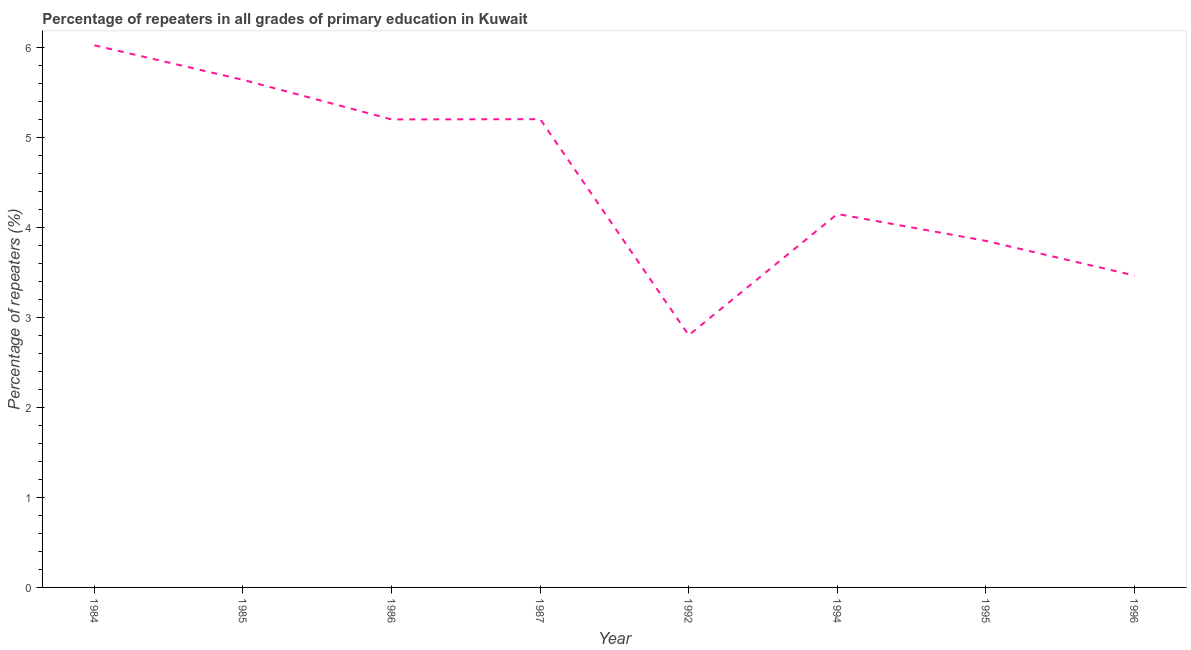What is the percentage of repeaters in primary education in 1994?
Keep it short and to the point. 4.15. Across all years, what is the maximum percentage of repeaters in primary education?
Make the answer very short. 6.03. Across all years, what is the minimum percentage of repeaters in primary education?
Provide a succinct answer. 2.8. What is the sum of the percentage of repeaters in primary education?
Offer a very short reply. 36.35. What is the difference between the percentage of repeaters in primary education in 1985 and 1987?
Ensure brevity in your answer.  0.44. What is the average percentage of repeaters in primary education per year?
Offer a terse response. 4.54. What is the median percentage of repeaters in primary education?
Provide a short and direct response. 4.68. What is the ratio of the percentage of repeaters in primary education in 1986 to that in 1992?
Offer a terse response. 1.86. What is the difference between the highest and the second highest percentage of repeaters in primary education?
Your answer should be compact. 0.38. Is the sum of the percentage of repeaters in primary education in 1987 and 1992 greater than the maximum percentage of repeaters in primary education across all years?
Provide a short and direct response. Yes. What is the difference between the highest and the lowest percentage of repeaters in primary education?
Your answer should be very brief. 3.22. In how many years, is the percentage of repeaters in primary education greater than the average percentage of repeaters in primary education taken over all years?
Keep it short and to the point. 4. Does the percentage of repeaters in primary education monotonically increase over the years?
Give a very brief answer. No. How many lines are there?
Your answer should be very brief. 1. How many years are there in the graph?
Offer a terse response. 8. What is the difference between two consecutive major ticks on the Y-axis?
Make the answer very short. 1. Are the values on the major ticks of Y-axis written in scientific E-notation?
Ensure brevity in your answer.  No. Does the graph contain any zero values?
Ensure brevity in your answer.  No. What is the title of the graph?
Your answer should be very brief. Percentage of repeaters in all grades of primary education in Kuwait. What is the label or title of the Y-axis?
Make the answer very short. Percentage of repeaters (%). What is the Percentage of repeaters (%) in 1984?
Provide a succinct answer. 6.03. What is the Percentage of repeaters (%) in 1985?
Provide a short and direct response. 5.64. What is the Percentage of repeaters (%) of 1986?
Offer a terse response. 5.2. What is the Percentage of repeaters (%) in 1987?
Your answer should be compact. 5.2. What is the Percentage of repeaters (%) of 1992?
Your answer should be compact. 2.8. What is the Percentage of repeaters (%) of 1994?
Your answer should be very brief. 4.15. What is the Percentage of repeaters (%) in 1995?
Your answer should be very brief. 3.85. What is the Percentage of repeaters (%) in 1996?
Provide a short and direct response. 3.47. What is the difference between the Percentage of repeaters (%) in 1984 and 1985?
Offer a very short reply. 0.38. What is the difference between the Percentage of repeaters (%) in 1984 and 1986?
Your response must be concise. 0.82. What is the difference between the Percentage of repeaters (%) in 1984 and 1987?
Make the answer very short. 0.82. What is the difference between the Percentage of repeaters (%) in 1984 and 1992?
Provide a short and direct response. 3.22. What is the difference between the Percentage of repeaters (%) in 1984 and 1994?
Offer a very short reply. 1.87. What is the difference between the Percentage of repeaters (%) in 1984 and 1995?
Ensure brevity in your answer.  2.17. What is the difference between the Percentage of repeaters (%) in 1984 and 1996?
Provide a succinct answer. 2.56. What is the difference between the Percentage of repeaters (%) in 1985 and 1986?
Offer a terse response. 0.44. What is the difference between the Percentage of repeaters (%) in 1985 and 1987?
Your answer should be very brief. 0.44. What is the difference between the Percentage of repeaters (%) in 1985 and 1992?
Keep it short and to the point. 2.84. What is the difference between the Percentage of repeaters (%) in 1985 and 1994?
Your answer should be very brief. 1.49. What is the difference between the Percentage of repeaters (%) in 1985 and 1995?
Offer a very short reply. 1.79. What is the difference between the Percentage of repeaters (%) in 1985 and 1996?
Ensure brevity in your answer.  2.18. What is the difference between the Percentage of repeaters (%) in 1986 and 1987?
Your answer should be compact. -0. What is the difference between the Percentage of repeaters (%) in 1986 and 1992?
Make the answer very short. 2.4. What is the difference between the Percentage of repeaters (%) in 1986 and 1994?
Keep it short and to the point. 1.05. What is the difference between the Percentage of repeaters (%) in 1986 and 1995?
Your answer should be very brief. 1.35. What is the difference between the Percentage of repeaters (%) in 1986 and 1996?
Keep it short and to the point. 1.74. What is the difference between the Percentage of repeaters (%) in 1987 and 1992?
Provide a succinct answer. 2.4. What is the difference between the Percentage of repeaters (%) in 1987 and 1994?
Ensure brevity in your answer.  1.05. What is the difference between the Percentage of repeaters (%) in 1987 and 1995?
Provide a short and direct response. 1.35. What is the difference between the Percentage of repeaters (%) in 1987 and 1996?
Your response must be concise. 1.74. What is the difference between the Percentage of repeaters (%) in 1992 and 1994?
Keep it short and to the point. -1.35. What is the difference between the Percentage of repeaters (%) in 1992 and 1995?
Make the answer very short. -1.05. What is the difference between the Percentage of repeaters (%) in 1992 and 1996?
Keep it short and to the point. -0.66. What is the difference between the Percentage of repeaters (%) in 1994 and 1995?
Make the answer very short. 0.3. What is the difference between the Percentage of repeaters (%) in 1994 and 1996?
Provide a short and direct response. 0.68. What is the difference between the Percentage of repeaters (%) in 1995 and 1996?
Your response must be concise. 0.39. What is the ratio of the Percentage of repeaters (%) in 1984 to that in 1985?
Keep it short and to the point. 1.07. What is the ratio of the Percentage of repeaters (%) in 1984 to that in 1986?
Ensure brevity in your answer.  1.16. What is the ratio of the Percentage of repeaters (%) in 1984 to that in 1987?
Make the answer very short. 1.16. What is the ratio of the Percentage of repeaters (%) in 1984 to that in 1992?
Ensure brevity in your answer.  2.15. What is the ratio of the Percentage of repeaters (%) in 1984 to that in 1994?
Offer a very short reply. 1.45. What is the ratio of the Percentage of repeaters (%) in 1984 to that in 1995?
Ensure brevity in your answer.  1.56. What is the ratio of the Percentage of repeaters (%) in 1984 to that in 1996?
Make the answer very short. 1.74. What is the ratio of the Percentage of repeaters (%) in 1985 to that in 1986?
Ensure brevity in your answer.  1.08. What is the ratio of the Percentage of repeaters (%) in 1985 to that in 1987?
Your answer should be very brief. 1.08. What is the ratio of the Percentage of repeaters (%) in 1985 to that in 1992?
Offer a terse response. 2.01. What is the ratio of the Percentage of repeaters (%) in 1985 to that in 1994?
Ensure brevity in your answer.  1.36. What is the ratio of the Percentage of repeaters (%) in 1985 to that in 1995?
Offer a very short reply. 1.47. What is the ratio of the Percentage of repeaters (%) in 1985 to that in 1996?
Keep it short and to the point. 1.63. What is the ratio of the Percentage of repeaters (%) in 1986 to that in 1992?
Make the answer very short. 1.85. What is the ratio of the Percentage of repeaters (%) in 1986 to that in 1994?
Make the answer very short. 1.25. What is the ratio of the Percentage of repeaters (%) in 1986 to that in 1995?
Offer a terse response. 1.35. What is the ratio of the Percentage of repeaters (%) in 1986 to that in 1996?
Give a very brief answer. 1.5. What is the ratio of the Percentage of repeaters (%) in 1987 to that in 1992?
Give a very brief answer. 1.86. What is the ratio of the Percentage of repeaters (%) in 1987 to that in 1994?
Your response must be concise. 1.25. What is the ratio of the Percentage of repeaters (%) in 1987 to that in 1995?
Your response must be concise. 1.35. What is the ratio of the Percentage of repeaters (%) in 1987 to that in 1996?
Give a very brief answer. 1.5. What is the ratio of the Percentage of repeaters (%) in 1992 to that in 1994?
Keep it short and to the point. 0.68. What is the ratio of the Percentage of repeaters (%) in 1992 to that in 1995?
Your answer should be compact. 0.73. What is the ratio of the Percentage of repeaters (%) in 1992 to that in 1996?
Your response must be concise. 0.81. What is the ratio of the Percentage of repeaters (%) in 1994 to that in 1995?
Ensure brevity in your answer.  1.08. What is the ratio of the Percentage of repeaters (%) in 1994 to that in 1996?
Your answer should be compact. 1.2. What is the ratio of the Percentage of repeaters (%) in 1995 to that in 1996?
Ensure brevity in your answer.  1.11. 